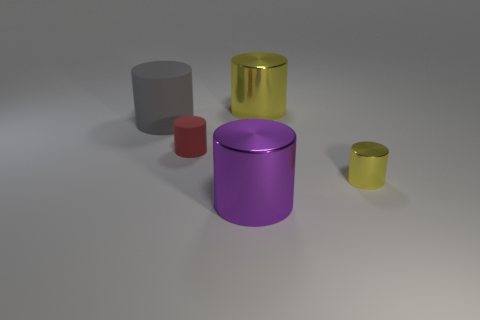What number of big purple metallic cylinders are behind the tiny red object?
Your response must be concise. 0. Is there a metal thing of the same size as the gray cylinder?
Give a very brief answer. Yes. Is there a sphere of the same color as the large rubber object?
Give a very brief answer. No. How many big shiny cylinders are the same color as the small shiny object?
Your answer should be compact. 1. Is the color of the small metallic thing the same as the metal cylinder that is behind the tiny yellow cylinder?
Keep it short and to the point. Yes. What number of things are either gray matte things or yellow metal cylinders on the right side of the big yellow object?
Your answer should be compact. 2. There is a purple shiny cylinder that is in front of the tiny object that is right of the small red matte thing; what size is it?
Give a very brief answer. Large. Are there the same number of small metal objects that are in front of the small red rubber cylinder and metal objects to the left of the large matte object?
Offer a terse response. No. Is there a small red matte cylinder that is in front of the yellow thing in front of the large yellow metallic thing?
Offer a terse response. No. There is a large yellow object that is the same material as the purple cylinder; what shape is it?
Provide a short and direct response. Cylinder. 